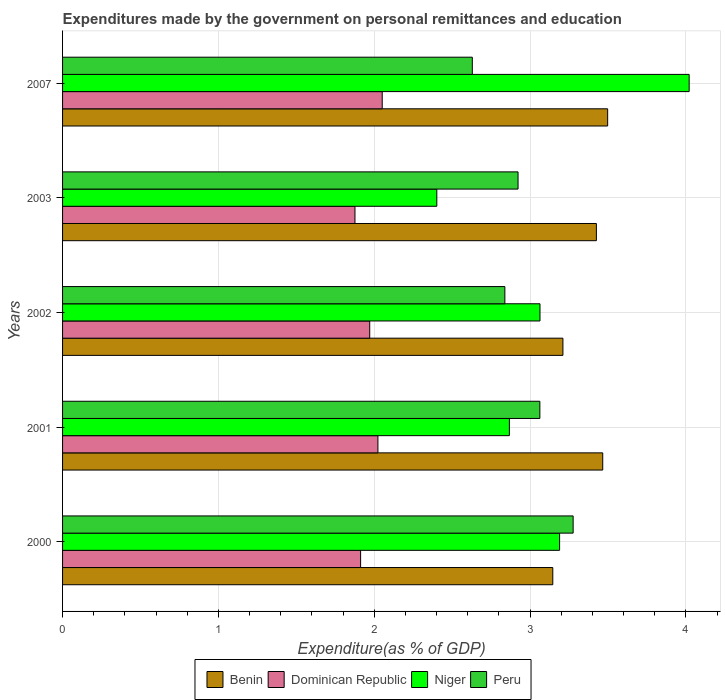How many different coloured bars are there?
Your response must be concise. 4. Are the number of bars per tick equal to the number of legend labels?
Give a very brief answer. Yes. Are the number of bars on each tick of the Y-axis equal?
Provide a short and direct response. Yes. How many bars are there on the 4th tick from the top?
Offer a terse response. 4. What is the expenditures made by the government on personal remittances and education in Benin in 2002?
Your answer should be very brief. 3.21. Across all years, what is the maximum expenditures made by the government on personal remittances and education in Benin?
Make the answer very short. 3.5. Across all years, what is the minimum expenditures made by the government on personal remittances and education in Dominican Republic?
Keep it short and to the point. 1.88. In which year was the expenditures made by the government on personal remittances and education in Benin maximum?
Keep it short and to the point. 2007. What is the total expenditures made by the government on personal remittances and education in Benin in the graph?
Keep it short and to the point. 16.75. What is the difference between the expenditures made by the government on personal remittances and education in Peru in 2002 and that in 2007?
Make the answer very short. 0.21. What is the difference between the expenditures made by the government on personal remittances and education in Dominican Republic in 2001 and the expenditures made by the government on personal remittances and education in Peru in 2002?
Ensure brevity in your answer.  -0.81. What is the average expenditures made by the government on personal remittances and education in Dominican Republic per year?
Provide a short and direct response. 1.97. In the year 2001, what is the difference between the expenditures made by the government on personal remittances and education in Dominican Republic and expenditures made by the government on personal remittances and education in Benin?
Your response must be concise. -1.44. In how many years, is the expenditures made by the government on personal remittances and education in Dominican Republic greater than 1 %?
Make the answer very short. 5. What is the ratio of the expenditures made by the government on personal remittances and education in Benin in 2000 to that in 2003?
Provide a succinct answer. 0.92. Is the expenditures made by the government on personal remittances and education in Niger in 2000 less than that in 2007?
Offer a very short reply. Yes. What is the difference between the highest and the second highest expenditures made by the government on personal remittances and education in Benin?
Provide a succinct answer. 0.03. What is the difference between the highest and the lowest expenditures made by the government on personal remittances and education in Dominican Republic?
Offer a very short reply. 0.17. In how many years, is the expenditures made by the government on personal remittances and education in Peru greater than the average expenditures made by the government on personal remittances and education in Peru taken over all years?
Provide a succinct answer. 2. What does the 3rd bar from the top in 2002 represents?
Make the answer very short. Dominican Republic. What does the 1st bar from the bottom in 2007 represents?
Give a very brief answer. Benin. Are all the bars in the graph horizontal?
Your answer should be compact. Yes. What is the difference between two consecutive major ticks on the X-axis?
Ensure brevity in your answer.  1. Does the graph contain any zero values?
Offer a terse response. No. Does the graph contain grids?
Your response must be concise. Yes. How many legend labels are there?
Ensure brevity in your answer.  4. How are the legend labels stacked?
Your answer should be compact. Horizontal. What is the title of the graph?
Provide a succinct answer. Expenditures made by the government on personal remittances and education. What is the label or title of the X-axis?
Your answer should be compact. Expenditure(as % of GDP). What is the Expenditure(as % of GDP) in Benin in 2000?
Ensure brevity in your answer.  3.15. What is the Expenditure(as % of GDP) in Dominican Republic in 2000?
Your answer should be very brief. 1.91. What is the Expenditure(as % of GDP) of Niger in 2000?
Your answer should be very brief. 3.19. What is the Expenditure(as % of GDP) of Peru in 2000?
Your answer should be compact. 3.28. What is the Expenditure(as % of GDP) in Benin in 2001?
Your answer should be compact. 3.47. What is the Expenditure(as % of GDP) of Dominican Republic in 2001?
Provide a succinct answer. 2.02. What is the Expenditure(as % of GDP) of Niger in 2001?
Your answer should be compact. 2.87. What is the Expenditure(as % of GDP) of Peru in 2001?
Your answer should be very brief. 3.06. What is the Expenditure(as % of GDP) of Benin in 2002?
Your response must be concise. 3.21. What is the Expenditure(as % of GDP) in Dominican Republic in 2002?
Your response must be concise. 1.97. What is the Expenditure(as % of GDP) in Niger in 2002?
Provide a succinct answer. 3.06. What is the Expenditure(as % of GDP) in Peru in 2002?
Keep it short and to the point. 2.84. What is the Expenditure(as % of GDP) of Benin in 2003?
Ensure brevity in your answer.  3.43. What is the Expenditure(as % of GDP) of Dominican Republic in 2003?
Offer a terse response. 1.88. What is the Expenditure(as % of GDP) in Niger in 2003?
Provide a succinct answer. 2.4. What is the Expenditure(as % of GDP) in Peru in 2003?
Keep it short and to the point. 2.92. What is the Expenditure(as % of GDP) of Benin in 2007?
Offer a very short reply. 3.5. What is the Expenditure(as % of GDP) of Dominican Republic in 2007?
Provide a short and direct response. 2.05. What is the Expenditure(as % of GDP) of Niger in 2007?
Your answer should be very brief. 4.02. What is the Expenditure(as % of GDP) of Peru in 2007?
Your response must be concise. 2.63. Across all years, what is the maximum Expenditure(as % of GDP) in Benin?
Ensure brevity in your answer.  3.5. Across all years, what is the maximum Expenditure(as % of GDP) in Dominican Republic?
Provide a succinct answer. 2.05. Across all years, what is the maximum Expenditure(as % of GDP) in Niger?
Your answer should be very brief. 4.02. Across all years, what is the maximum Expenditure(as % of GDP) in Peru?
Your response must be concise. 3.28. Across all years, what is the minimum Expenditure(as % of GDP) in Benin?
Your answer should be very brief. 3.15. Across all years, what is the minimum Expenditure(as % of GDP) of Dominican Republic?
Offer a terse response. 1.88. Across all years, what is the minimum Expenditure(as % of GDP) in Niger?
Provide a short and direct response. 2.4. Across all years, what is the minimum Expenditure(as % of GDP) of Peru?
Offer a terse response. 2.63. What is the total Expenditure(as % of GDP) of Benin in the graph?
Give a very brief answer. 16.75. What is the total Expenditure(as % of GDP) in Dominican Republic in the graph?
Your response must be concise. 9.83. What is the total Expenditure(as % of GDP) of Niger in the graph?
Your answer should be compact. 15.54. What is the total Expenditure(as % of GDP) in Peru in the graph?
Your response must be concise. 14.73. What is the difference between the Expenditure(as % of GDP) in Benin in 2000 and that in 2001?
Make the answer very short. -0.32. What is the difference between the Expenditure(as % of GDP) of Dominican Republic in 2000 and that in 2001?
Keep it short and to the point. -0.11. What is the difference between the Expenditure(as % of GDP) in Niger in 2000 and that in 2001?
Give a very brief answer. 0.32. What is the difference between the Expenditure(as % of GDP) in Peru in 2000 and that in 2001?
Provide a short and direct response. 0.21. What is the difference between the Expenditure(as % of GDP) of Benin in 2000 and that in 2002?
Your answer should be very brief. -0.07. What is the difference between the Expenditure(as % of GDP) in Dominican Republic in 2000 and that in 2002?
Your answer should be compact. -0.06. What is the difference between the Expenditure(as % of GDP) in Niger in 2000 and that in 2002?
Provide a short and direct response. 0.13. What is the difference between the Expenditure(as % of GDP) in Peru in 2000 and that in 2002?
Provide a succinct answer. 0.44. What is the difference between the Expenditure(as % of GDP) of Benin in 2000 and that in 2003?
Make the answer very short. -0.28. What is the difference between the Expenditure(as % of GDP) of Dominican Republic in 2000 and that in 2003?
Your answer should be very brief. 0.04. What is the difference between the Expenditure(as % of GDP) of Niger in 2000 and that in 2003?
Ensure brevity in your answer.  0.79. What is the difference between the Expenditure(as % of GDP) in Peru in 2000 and that in 2003?
Your response must be concise. 0.35. What is the difference between the Expenditure(as % of GDP) of Benin in 2000 and that in 2007?
Provide a short and direct response. -0.35. What is the difference between the Expenditure(as % of GDP) of Dominican Republic in 2000 and that in 2007?
Offer a terse response. -0.14. What is the difference between the Expenditure(as % of GDP) in Niger in 2000 and that in 2007?
Provide a succinct answer. -0.83. What is the difference between the Expenditure(as % of GDP) in Peru in 2000 and that in 2007?
Your response must be concise. 0.65. What is the difference between the Expenditure(as % of GDP) of Benin in 2001 and that in 2002?
Offer a terse response. 0.26. What is the difference between the Expenditure(as % of GDP) of Dominican Republic in 2001 and that in 2002?
Keep it short and to the point. 0.05. What is the difference between the Expenditure(as % of GDP) in Niger in 2001 and that in 2002?
Provide a succinct answer. -0.2. What is the difference between the Expenditure(as % of GDP) of Peru in 2001 and that in 2002?
Your answer should be very brief. 0.22. What is the difference between the Expenditure(as % of GDP) of Benin in 2001 and that in 2003?
Keep it short and to the point. 0.04. What is the difference between the Expenditure(as % of GDP) in Dominican Republic in 2001 and that in 2003?
Ensure brevity in your answer.  0.15. What is the difference between the Expenditure(as % of GDP) of Niger in 2001 and that in 2003?
Offer a terse response. 0.47. What is the difference between the Expenditure(as % of GDP) in Peru in 2001 and that in 2003?
Offer a very short reply. 0.14. What is the difference between the Expenditure(as % of GDP) of Benin in 2001 and that in 2007?
Give a very brief answer. -0.03. What is the difference between the Expenditure(as % of GDP) of Dominican Republic in 2001 and that in 2007?
Your answer should be very brief. -0.03. What is the difference between the Expenditure(as % of GDP) in Niger in 2001 and that in 2007?
Your answer should be compact. -1.15. What is the difference between the Expenditure(as % of GDP) in Peru in 2001 and that in 2007?
Provide a succinct answer. 0.43. What is the difference between the Expenditure(as % of GDP) in Benin in 2002 and that in 2003?
Provide a short and direct response. -0.21. What is the difference between the Expenditure(as % of GDP) in Dominican Republic in 2002 and that in 2003?
Provide a succinct answer. 0.09. What is the difference between the Expenditure(as % of GDP) of Niger in 2002 and that in 2003?
Give a very brief answer. 0.66. What is the difference between the Expenditure(as % of GDP) of Peru in 2002 and that in 2003?
Your answer should be very brief. -0.08. What is the difference between the Expenditure(as % of GDP) of Benin in 2002 and that in 2007?
Your answer should be compact. -0.29. What is the difference between the Expenditure(as % of GDP) in Dominican Republic in 2002 and that in 2007?
Your response must be concise. -0.08. What is the difference between the Expenditure(as % of GDP) of Niger in 2002 and that in 2007?
Your answer should be very brief. -0.96. What is the difference between the Expenditure(as % of GDP) in Peru in 2002 and that in 2007?
Make the answer very short. 0.21. What is the difference between the Expenditure(as % of GDP) of Benin in 2003 and that in 2007?
Ensure brevity in your answer.  -0.07. What is the difference between the Expenditure(as % of GDP) of Dominican Republic in 2003 and that in 2007?
Provide a short and direct response. -0.17. What is the difference between the Expenditure(as % of GDP) of Niger in 2003 and that in 2007?
Provide a short and direct response. -1.62. What is the difference between the Expenditure(as % of GDP) in Peru in 2003 and that in 2007?
Make the answer very short. 0.29. What is the difference between the Expenditure(as % of GDP) in Benin in 2000 and the Expenditure(as % of GDP) in Dominican Republic in 2001?
Your answer should be very brief. 1.12. What is the difference between the Expenditure(as % of GDP) in Benin in 2000 and the Expenditure(as % of GDP) in Niger in 2001?
Give a very brief answer. 0.28. What is the difference between the Expenditure(as % of GDP) of Benin in 2000 and the Expenditure(as % of GDP) of Peru in 2001?
Keep it short and to the point. 0.08. What is the difference between the Expenditure(as % of GDP) in Dominican Republic in 2000 and the Expenditure(as % of GDP) in Niger in 2001?
Give a very brief answer. -0.95. What is the difference between the Expenditure(as % of GDP) of Dominican Republic in 2000 and the Expenditure(as % of GDP) of Peru in 2001?
Provide a short and direct response. -1.15. What is the difference between the Expenditure(as % of GDP) of Niger in 2000 and the Expenditure(as % of GDP) of Peru in 2001?
Offer a terse response. 0.13. What is the difference between the Expenditure(as % of GDP) in Benin in 2000 and the Expenditure(as % of GDP) in Dominican Republic in 2002?
Your answer should be very brief. 1.17. What is the difference between the Expenditure(as % of GDP) of Benin in 2000 and the Expenditure(as % of GDP) of Niger in 2002?
Ensure brevity in your answer.  0.08. What is the difference between the Expenditure(as % of GDP) of Benin in 2000 and the Expenditure(as % of GDP) of Peru in 2002?
Give a very brief answer. 0.31. What is the difference between the Expenditure(as % of GDP) in Dominican Republic in 2000 and the Expenditure(as % of GDP) in Niger in 2002?
Your response must be concise. -1.15. What is the difference between the Expenditure(as % of GDP) of Dominican Republic in 2000 and the Expenditure(as % of GDP) of Peru in 2002?
Offer a very short reply. -0.93. What is the difference between the Expenditure(as % of GDP) of Niger in 2000 and the Expenditure(as % of GDP) of Peru in 2002?
Your response must be concise. 0.35. What is the difference between the Expenditure(as % of GDP) of Benin in 2000 and the Expenditure(as % of GDP) of Dominican Republic in 2003?
Provide a short and direct response. 1.27. What is the difference between the Expenditure(as % of GDP) in Benin in 2000 and the Expenditure(as % of GDP) in Niger in 2003?
Offer a very short reply. 0.74. What is the difference between the Expenditure(as % of GDP) of Benin in 2000 and the Expenditure(as % of GDP) of Peru in 2003?
Provide a short and direct response. 0.22. What is the difference between the Expenditure(as % of GDP) of Dominican Republic in 2000 and the Expenditure(as % of GDP) of Niger in 2003?
Provide a short and direct response. -0.49. What is the difference between the Expenditure(as % of GDP) in Dominican Republic in 2000 and the Expenditure(as % of GDP) in Peru in 2003?
Offer a very short reply. -1.01. What is the difference between the Expenditure(as % of GDP) of Niger in 2000 and the Expenditure(as % of GDP) of Peru in 2003?
Give a very brief answer. 0.27. What is the difference between the Expenditure(as % of GDP) in Benin in 2000 and the Expenditure(as % of GDP) in Dominican Republic in 2007?
Offer a terse response. 1.09. What is the difference between the Expenditure(as % of GDP) of Benin in 2000 and the Expenditure(as % of GDP) of Niger in 2007?
Ensure brevity in your answer.  -0.88. What is the difference between the Expenditure(as % of GDP) in Benin in 2000 and the Expenditure(as % of GDP) in Peru in 2007?
Provide a succinct answer. 0.52. What is the difference between the Expenditure(as % of GDP) in Dominican Republic in 2000 and the Expenditure(as % of GDP) in Niger in 2007?
Your answer should be very brief. -2.11. What is the difference between the Expenditure(as % of GDP) of Dominican Republic in 2000 and the Expenditure(as % of GDP) of Peru in 2007?
Offer a very short reply. -0.72. What is the difference between the Expenditure(as % of GDP) in Niger in 2000 and the Expenditure(as % of GDP) in Peru in 2007?
Keep it short and to the point. 0.56. What is the difference between the Expenditure(as % of GDP) in Benin in 2001 and the Expenditure(as % of GDP) in Dominican Republic in 2002?
Provide a short and direct response. 1.5. What is the difference between the Expenditure(as % of GDP) of Benin in 2001 and the Expenditure(as % of GDP) of Niger in 2002?
Offer a very short reply. 0.4. What is the difference between the Expenditure(as % of GDP) in Benin in 2001 and the Expenditure(as % of GDP) in Peru in 2002?
Offer a very short reply. 0.63. What is the difference between the Expenditure(as % of GDP) of Dominican Republic in 2001 and the Expenditure(as % of GDP) of Niger in 2002?
Provide a short and direct response. -1.04. What is the difference between the Expenditure(as % of GDP) of Dominican Republic in 2001 and the Expenditure(as % of GDP) of Peru in 2002?
Your answer should be very brief. -0.81. What is the difference between the Expenditure(as % of GDP) in Niger in 2001 and the Expenditure(as % of GDP) in Peru in 2002?
Your answer should be compact. 0.03. What is the difference between the Expenditure(as % of GDP) of Benin in 2001 and the Expenditure(as % of GDP) of Dominican Republic in 2003?
Keep it short and to the point. 1.59. What is the difference between the Expenditure(as % of GDP) in Benin in 2001 and the Expenditure(as % of GDP) in Niger in 2003?
Ensure brevity in your answer.  1.06. What is the difference between the Expenditure(as % of GDP) in Benin in 2001 and the Expenditure(as % of GDP) in Peru in 2003?
Your answer should be compact. 0.54. What is the difference between the Expenditure(as % of GDP) of Dominican Republic in 2001 and the Expenditure(as % of GDP) of Niger in 2003?
Your answer should be very brief. -0.38. What is the difference between the Expenditure(as % of GDP) in Dominican Republic in 2001 and the Expenditure(as % of GDP) in Peru in 2003?
Ensure brevity in your answer.  -0.9. What is the difference between the Expenditure(as % of GDP) in Niger in 2001 and the Expenditure(as % of GDP) in Peru in 2003?
Make the answer very short. -0.06. What is the difference between the Expenditure(as % of GDP) in Benin in 2001 and the Expenditure(as % of GDP) in Dominican Republic in 2007?
Your response must be concise. 1.42. What is the difference between the Expenditure(as % of GDP) in Benin in 2001 and the Expenditure(as % of GDP) in Niger in 2007?
Make the answer very short. -0.55. What is the difference between the Expenditure(as % of GDP) in Benin in 2001 and the Expenditure(as % of GDP) in Peru in 2007?
Keep it short and to the point. 0.84. What is the difference between the Expenditure(as % of GDP) of Dominican Republic in 2001 and the Expenditure(as % of GDP) of Niger in 2007?
Make the answer very short. -2. What is the difference between the Expenditure(as % of GDP) of Dominican Republic in 2001 and the Expenditure(as % of GDP) of Peru in 2007?
Your answer should be compact. -0.61. What is the difference between the Expenditure(as % of GDP) of Niger in 2001 and the Expenditure(as % of GDP) of Peru in 2007?
Provide a succinct answer. 0.24. What is the difference between the Expenditure(as % of GDP) of Benin in 2002 and the Expenditure(as % of GDP) of Dominican Republic in 2003?
Your answer should be compact. 1.33. What is the difference between the Expenditure(as % of GDP) in Benin in 2002 and the Expenditure(as % of GDP) in Niger in 2003?
Give a very brief answer. 0.81. What is the difference between the Expenditure(as % of GDP) in Benin in 2002 and the Expenditure(as % of GDP) in Peru in 2003?
Provide a short and direct response. 0.29. What is the difference between the Expenditure(as % of GDP) in Dominican Republic in 2002 and the Expenditure(as % of GDP) in Niger in 2003?
Ensure brevity in your answer.  -0.43. What is the difference between the Expenditure(as % of GDP) in Dominican Republic in 2002 and the Expenditure(as % of GDP) in Peru in 2003?
Give a very brief answer. -0.95. What is the difference between the Expenditure(as % of GDP) of Niger in 2002 and the Expenditure(as % of GDP) of Peru in 2003?
Provide a succinct answer. 0.14. What is the difference between the Expenditure(as % of GDP) of Benin in 2002 and the Expenditure(as % of GDP) of Dominican Republic in 2007?
Ensure brevity in your answer.  1.16. What is the difference between the Expenditure(as % of GDP) in Benin in 2002 and the Expenditure(as % of GDP) in Niger in 2007?
Provide a short and direct response. -0.81. What is the difference between the Expenditure(as % of GDP) of Benin in 2002 and the Expenditure(as % of GDP) of Peru in 2007?
Provide a succinct answer. 0.58. What is the difference between the Expenditure(as % of GDP) in Dominican Republic in 2002 and the Expenditure(as % of GDP) in Niger in 2007?
Ensure brevity in your answer.  -2.05. What is the difference between the Expenditure(as % of GDP) in Dominican Republic in 2002 and the Expenditure(as % of GDP) in Peru in 2007?
Provide a succinct answer. -0.66. What is the difference between the Expenditure(as % of GDP) in Niger in 2002 and the Expenditure(as % of GDP) in Peru in 2007?
Your answer should be very brief. 0.43. What is the difference between the Expenditure(as % of GDP) in Benin in 2003 and the Expenditure(as % of GDP) in Dominican Republic in 2007?
Ensure brevity in your answer.  1.37. What is the difference between the Expenditure(as % of GDP) in Benin in 2003 and the Expenditure(as % of GDP) in Niger in 2007?
Give a very brief answer. -0.6. What is the difference between the Expenditure(as % of GDP) in Benin in 2003 and the Expenditure(as % of GDP) in Peru in 2007?
Offer a very short reply. 0.8. What is the difference between the Expenditure(as % of GDP) of Dominican Republic in 2003 and the Expenditure(as % of GDP) of Niger in 2007?
Ensure brevity in your answer.  -2.14. What is the difference between the Expenditure(as % of GDP) of Dominican Republic in 2003 and the Expenditure(as % of GDP) of Peru in 2007?
Provide a short and direct response. -0.75. What is the difference between the Expenditure(as % of GDP) of Niger in 2003 and the Expenditure(as % of GDP) of Peru in 2007?
Provide a succinct answer. -0.23. What is the average Expenditure(as % of GDP) in Benin per year?
Your answer should be very brief. 3.35. What is the average Expenditure(as % of GDP) of Dominican Republic per year?
Keep it short and to the point. 1.97. What is the average Expenditure(as % of GDP) in Niger per year?
Provide a succinct answer. 3.11. What is the average Expenditure(as % of GDP) in Peru per year?
Your response must be concise. 2.95. In the year 2000, what is the difference between the Expenditure(as % of GDP) in Benin and Expenditure(as % of GDP) in Dominican Republic?
Keep it short and to the point. 1.23. In the year 2000, what is the difference between the Expenditure(as % of GDP) of Benin and Expenditure(as % of GDP) of Niger?
Make the answer very short. -0.04. In the year 2000, what is the difference between the Expenditure(as % of GDP) in Benin and Expenditure(as % of GDP) in Peru?
Offer a terse response. -0.13. In the year 2000, what is the difference between the Expenditure(as % of GDP) in Dominican Republic and Expenditure(as % of GDP) in Niger?
Offer a very short reply. -1.28. In the year 2000, what is the difference between the Expenditure(as % of GDP) of Dominican Republic and Expenditure(as % of GDP) of Peru?
Offer a very short reply. -1.36. In the year 2000, what is the difference between the Expenditure(as % of GDP) in Niger and Expenditure(as % of GDP) in Peru?
Your answer should be very brief. -0.09. In the year 2001, what is the difference between the Expenditure(as % of GDP) of Benin and Expenditure(as % of GDP) of Dominican Republic?
Make the answer very short. 1.44. In the year 2001, what is the difference between the Expenditure(as % of GDP) of Benin and Expenditure(as % of GDP) of Niger?
Offer a terse response. 0.6. In the year 2001, what is the difference between the Expenditure(as % of GDP) of Benin and Expenditure(as % of GDP) of Peru?
Keep it short and to the point. 0.4. In the year 2001, what is the difference between the Expenditure(as % of GDP) in Dominican Republic and Expenditure(as % of GDP) in Niger?
Offer a terse response. -0.84. In the year 2001, what is the difference between the Expenditure(as % of GDP) in Dominican Republic and Expenditure(as % of GDP) in Peru?
Provide a succinct answer. -1.04. In the year 2001, what is the difference between the Expenditure(as % of GDP) of Niger and Expenditure(as % of GDP) of Peru?
Provide a short and direct response. -0.2. In the year 2002, what is the difference between the Expenditure(as % of GDP) in Benin and Expenditure(as % of GDP) in Dominican Republic?
Provide a short and direct response. 1.24. In the year 2002, what is the difference between the Expenditure(as % of GDP) in Benin and Expenditure(as % of GDP) in Niger?
Provide a succinct answer. 0.15. In the year 2002, what is the difference between the Expenditure(as % of GDP) of Benin and Expenditure(as % of GDP) of Peru?
Offer a very short reply. 0.37. In the year 2002, what is the difference between the Expenditure(as % of GDP) in Dominican Republic and Expenditure(as % of GDP) in Niger?
Your answer should be compact. -1.09. In the year 2002, what is the difference between the Expenditure(as % of GDP) in Dominican Republic and Expenditure(as % of GDP) in Peru?
Your answer should be very brief. -0.87. In the year 2002, what is the difference between the Expenditure(as % of GDP) of Niger and Expenditure(as % of GDP) of Peru?
Ensure brevity in your answer.  0.23. In the year 2003, what is the difference between the Expenditure(as % of GDP) of Benin and Expenditure(as % of GDP) of Dominican Republic?
Your answer should be compact. 1.55. In the year 2003, what is the difference between the Expenditure(as % of GDP) of Benin and Expenditure(as % of GDP) of Peru?
Offer a terse response. 0.5. In the year 2003, what is the difference between the Expenditure(as % of GDP) of Dominican Republic and Expenditure(as % of GDP) of Niger?
Ensure brevity in your answer.  -0.53. In the year 2003, what is the difference between the Expenditure(as % of GDP) in Dominican Republic and Expenditure(as % of GDP) in Peru?
Offer a terse response. -1.05. In the year 2003, what is the difference between the Expenditure(as % of GDP) of Niger and Expenditure(as % of GDP) of Peru?
Your response must be concise. -0.52. In the year 2007, what is the difference between the Expenditure(as % of GDP) in Benin and Expenditure(as % of GDP) in Dominican Republic?
Give a very brief answer. 1.45. In the year 2007, what is the difference between the Expenditure(as % of GDP) of Benin and Expenditure(as % of GDP) of Niger?
Make the answer very short. -0.52. In the year 2007, what is the difference between the Expenditure(as % of GDP) of Benin and Expenditure(as % of GDP) of Peru?
Provide a succinct answer. 0.87. In the year 2007, what is the difference between the Expenditure(as % of GDP) in Dominican Republic and Expenditure(as % of GDP) in Niger?
Make the answer very short. -1.97. In the year 2007, what is the difference between the Expenditure(as % of GDP) of Dominican Republic and Expenditure(as % of GDP) of Peru?
Your answer should be very brief. -0.58. In the year 2007, what is the difference between the Expenditure(as % of GDP) in Niger and Expenditure(as % of GDP) in Peru?
Ensure brevity in your answer.  1.39. What is the ratio of the Expenditure(as % of GDP) in Benin in 2000 to that in 2001?
Your answer should be compact. 0.91. What is the ratio of the Expenditure(as % of GDP) in Dominican Republic in 2000 to that in 2001?
Give a very brief answer. 0.95. What is the ratio of the Expenditure(as % of GDP) in Niger in 2000 to that in 2001?
Provide a short and direct response. 1.11. What is the ratio of the Expenditure(as % of GDP) of Peru in 2000 to that in 2001?
Offer a very short reply. 1.07. What is the ratio of the Expenditure(as % of GDP) of Benin in 2000 to that in 2002?
Offer a very short reply. 0.98. What is the ratio of the Expenditure(as % of GDP) in Dominican Republic in 2000 to that in 2002?
Ensure brevity in your answer.  0.97. What is the ratio of the Expenditure(as % of GDP) in Niger in 2000 to that in 2002?
Your answer should be very brief. 1.04. What is the ratio of the Expenditure(as % of GDP) in Peru in 2000 to that in 2002?
Offer a terse response. 1.15. What is the ratio of the Expenditure(as % of GDP) of Benin in 2000 to that in 2003?
Make the answer very short. 0.92. What is the ratio of the Expenditure(as % of GDP) of Dominican Republic in 2000 to that in 2003?
Offer a terse response. 1.02. What is the ratio of the Expenditure(as % of GDP) in Niger in 2000 to that in 2003?
Offer a very short reply. 1.33. What is the ratio of the Expenditure(as % of GDP) of Peru in 2000 to that in 2003?
Offer a terse response. 1.12. What is the ratio of the Expenditure(as % of GDP) in Benin in 2000 to that in 2007?
Provide a succinct answer. 0.9. What is the ratio of the Expenditure(as % of GDP) of Dominican Republic in 2000 to that in 2007?
Your response must be concise. 0.93. What is the ratio of the Expenditure(as % of GDP) of Niger in 2000 to that in 2007?
Offer a very short reply. 0.79. What is the ratio of the Expenditure(as % of GDP) in Peru in 2000 to that in 2007?
Keep it short and to the point. 1.25. What is the ratio of the Expenditure(as % of GDP) in Benin in 2001 to that in 2002?
Ensure brevity in your answer.  1.08. What is the ratio of the Expenditure(as % of GDP) of Dominican Republic in 2001 to that in 2002?
Your response must be concise. 1.03. What is the ratio of the Expenditure(as % of GDP) of Niger in 2001 to that in 2002?
Ensure brevity in your answer.  0.94. What is the ratio of the Expenditure(as % of GDP) in Peru in 2001 to that in 2002?
Your response must be concise. 1.08. What is the ratio of the Expenditure(as % of GDP) of Benin in 2001 to that in 2003?
Your response must be concise. 1.01. What is the ratio of the Expenditure(as % of GDP) in Dominican Republic in 2001 to that in 2003?
Keep it short and to the point. 1.08. What is the ratio of the Expenditure(as % of GDP) in Niger in 2001 to that in 2003?
Make the answer very short. 1.19. What is the ratio of the Expenditure(as % of GDP) in Peru in 2001 to that in 2003?
Your response must be concise. 1.05. What is the ratio of the Expenditure(as % of GDP) in Benin in 2001 to that in 2007?
Your answer should be compact. 0.99. What is the ratio of the Expenditure(as % of GDP) in Dominican Republic in 2001 to that in 2007?
Your response must be concise. 0.99. What is the ratio of the Expenditure(as % of GDP) of Niger in 2001 to that in 2007?
Your answer should be very brief. 0.71. What is the ratio of the Expenditure(as % of GDP) in Peru in 2001 to that in 2007?
Keep it short and to the point. 1.16. What is the ratio of the Expenditure(as % of GDP) in Benin in 2002 to that in 2003?
Make the answer very short. 0.94. What is the ratio of the Expenditure(as % of GDP) of Dominican Republic in 2002 to that in 2003?
Your answer should be compact. 1.05. What is the ratio of the Expenditure(as % of GDP) of Niger in 2002 to that in 2003?
Your answer should be compact. 1.28. What is the ratio of the Expenditure(as % of GDP) of Peru in 2002 to that in 2003?
Give a very brief answer. 0.97. What is the ratio of the Expenditure(as % of GDP) of Benin in 2002 to that in 2007?
Your answer should be very brief. 0.92. What is the ratio of the Expenditure(as % of GDP) in Dominican Republic in 2002 to that in 2007?
Your answer should be very brief. 0.96. What is the ratio of the Expenditure(as % of GDP) in Niger in 2002 to that in 2007?
Offer a very short reply. 0.76. What is the ratio of the Expenditure(as % of GDP) in Peru in 2002 to that in 2007?
Give a very brief answer. 1.08. What is the ratio of the Expenditure(as % of GDP) of Benin in 2003 to that in 2007?
Offer a terse response. 0.98. What is the ratio of the Expenditure(as % of GDP) of Dominican Republic in 2003 to that in 2007?
Make the answer very short. 0.91. What is the ratio of the Expenditure(as % of GDP) of Niger in 2003 to that in 2007?
Your response must be concise. 0.6. What is the ratio of the Expenditure(as % of GDP) of Peru in 2003 to that in 2007?
Provide a succinct answer. 1.11. What is the difference between the highest and the second highest Expenditure(as % of GDP) in Benin?
Ensure brevity in your answer.  0.03. What is the difference between the highest and the second highest Expenditure(as % of GDP) in Dominican Republic?
Offer a terse response. 0.03. What is the difference between the highest and the second highest Expenditure(as % of GDP) in Niger?
Ensure brevity in your answer.  0.83. What is the difference between the highest and the second highest Expenditure(as % of GDP) in Peru?
Offer a terse response. 0.21. What is the difference between the highest and the lowest Expenditure(as % of GDP) in Benin?
Make the answer very short. 0.35. What is the difference between the highest and the lowest Expenditure(as % of GDP) of Dominican Republic?
Make the answer very short. 0.17. What is the difference between the highest and the lowest Expenditure(as % of GDP) of Niger?
Ensure brevity in your answer.  1.62. What is the difference between the highest and the lowest Expenditure(as % of GDP) in Peru?
Provide a short and direct response. 0.65. 